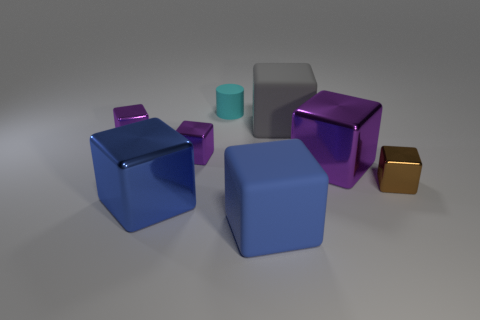How many purple blocks must be subtracted to get 1 purple blocks? 2 Subtract all purple cylinders. How many purple cubes are left? 3 Subtract all gray cubes. How many cubes are left? 6 Subtract all big purple blocks. How many blocks are left? 6 Subtract all yellow cubes. Subtract all purple cylinders. How many cubes are left? 7 Add 1 tiny cyan metallic spheres. How many objects exist? 9 Subtract all cylinders. How many objects are left? 7 Add 8 gray rubber blocks. How many gray rubber blocks are left? 9 Add 6 blue rubber blocks. How many blue rubber blocks exist? 7 Subtract 0 purple spheres. How many objects are left? 8 